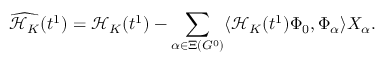Convert formula to latex. <formula><loc_0><loc_0><loc_500><loc_500>\widehat { \mathcal { H } _ { K } } ( t ^ { 1 } ) = \mathcal { H } _ { K } ( t ^ { 1 } ) - \sum _ { \alpha \in \Xi ( G ^ { 0 } ) } \langle \mathcal { H } _ { K } ( t ^ { 1 } ) \Phi _ { 0 } , \Phi _ { \alpha } \rangle X _ { \alpha } .</formula> 